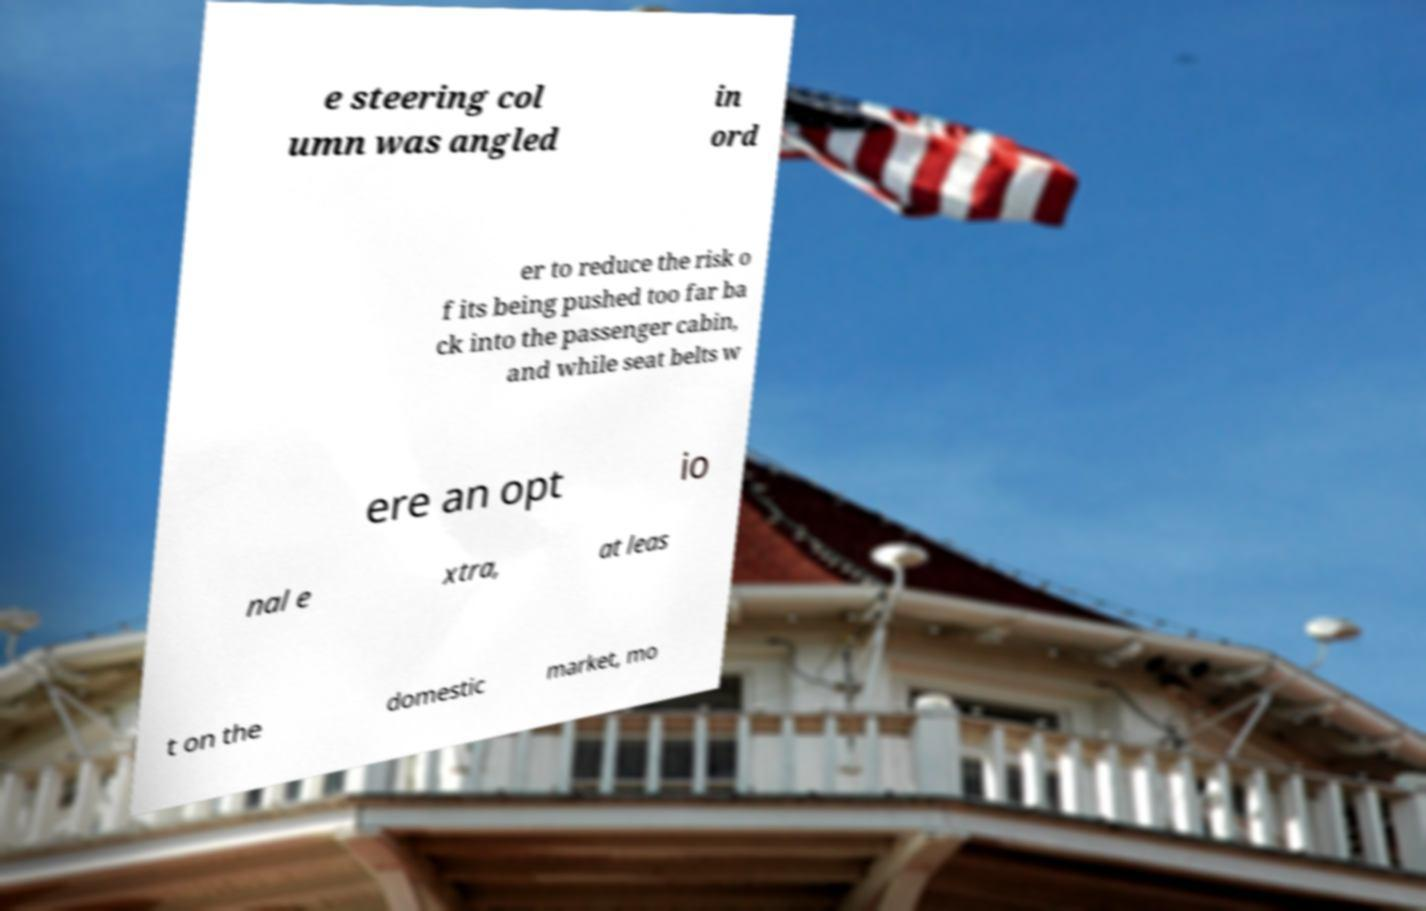Can you read and provide the text displayed in the image?This photo seems to have some interesting text. Can you extract and type it out for me? e steering col umn was angled in ord er to reduce the risk o f its being pushed too far ba ck into the passenger cabin, and while seat belts w ere an opt io nal e xtra, at leas t on the domestic market, mo 